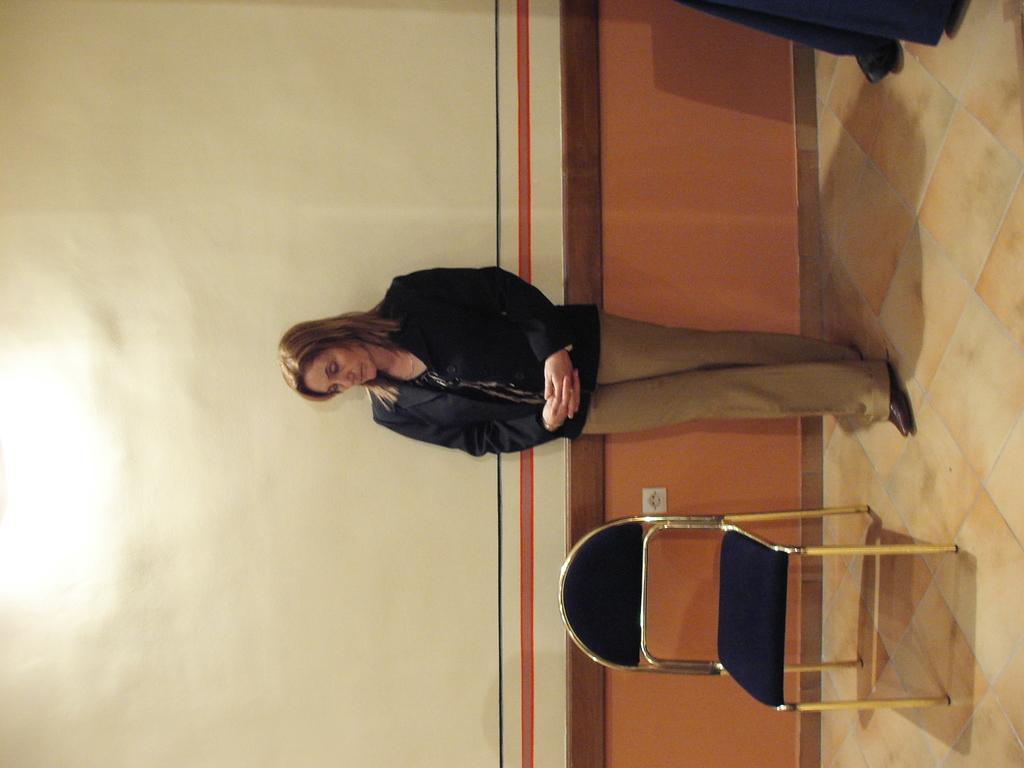Can you describe this image briefly? This image is rotated. In this image we can see there is a lady standing on the floor, beside the lady there is a chair. In the background there is a wall. 